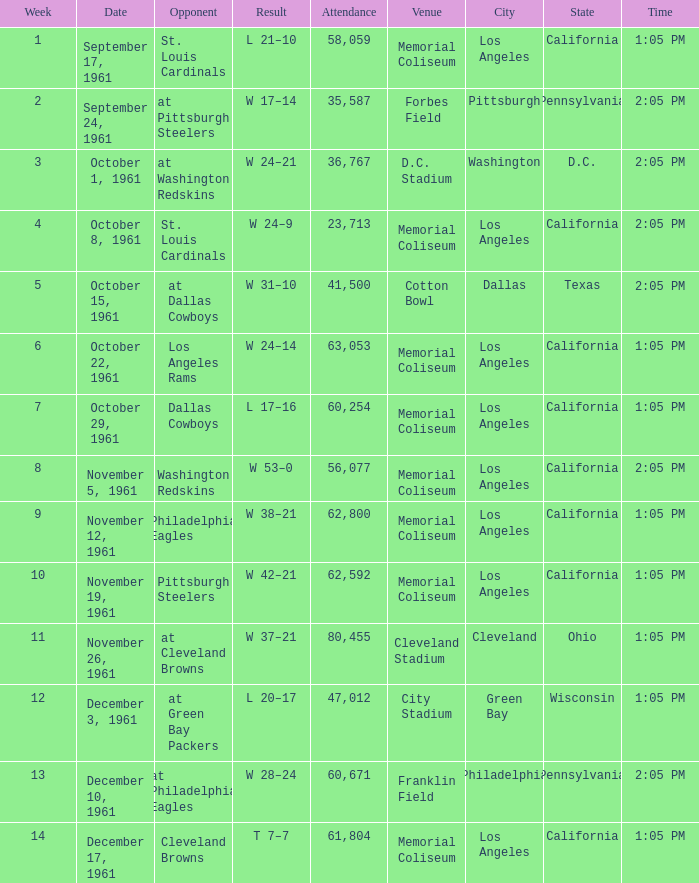What was the result on october 8, 1961? W 24–9. 